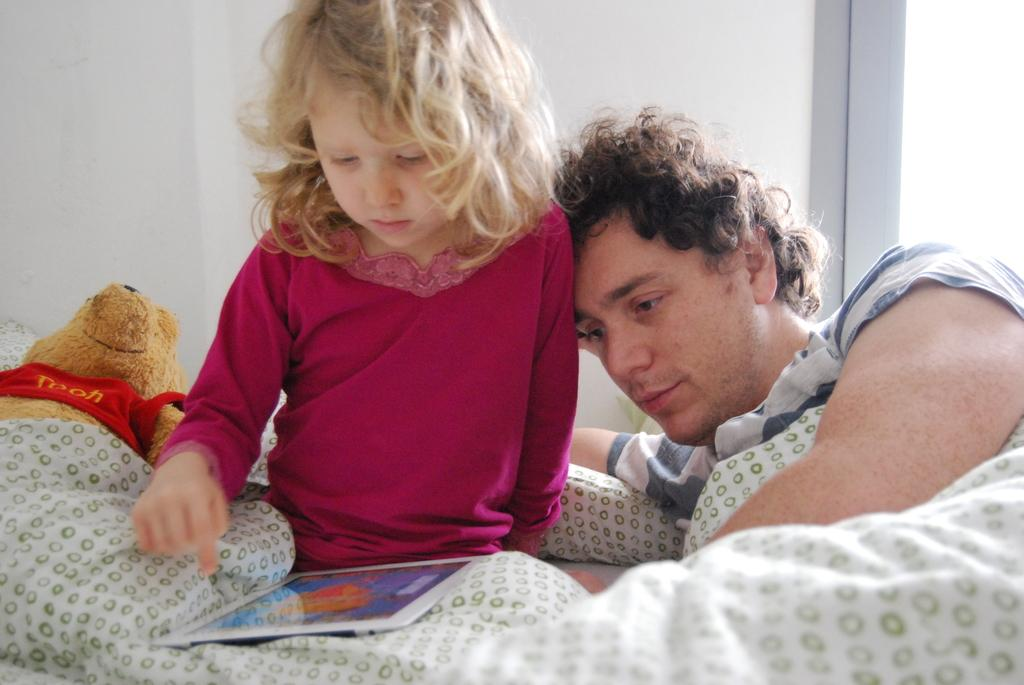What is the man doing in the image? The man is lying on the bed. What is the kid doing on the bed? The kid is sitting on the bed and looking at a tab. What items are on the bed? There is a blanket and a pillow on the bed. What object can be seen in the image besides the bed and the people? There is a toy in the image. What is visible in the background of the image? There is a wall in the background of the image. What type of garden can be seen through the window in the image? There is no window or garden present in the image. What color is the ink used to write the title of the book the kid is reading? There is no book or ink present in the image; the kid is looking at a tab. 